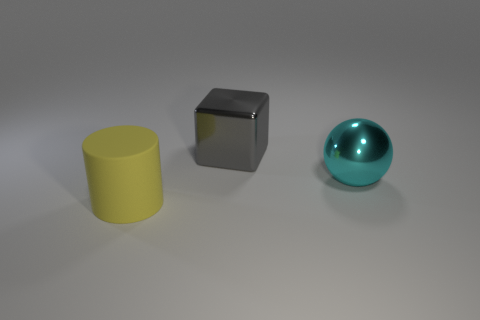Add 1 gray metallic cubes. How many objects exist? 4 Subtract all blocks. How many objects are left? 2 Subtract all purple cylinders. Subtract all yellow blocks. How many cylinders are left? 1 Subtract all small metal balls. Subtract all big rubber objects. How many objects are left? 2 Add 2 big blocks. How many big blocks are left? 3 Add 1 tiny gray matte spheres. How many tiny gray matte spheres exist? 1 Subtract 1 gray blocks. How many objects are left? 2 